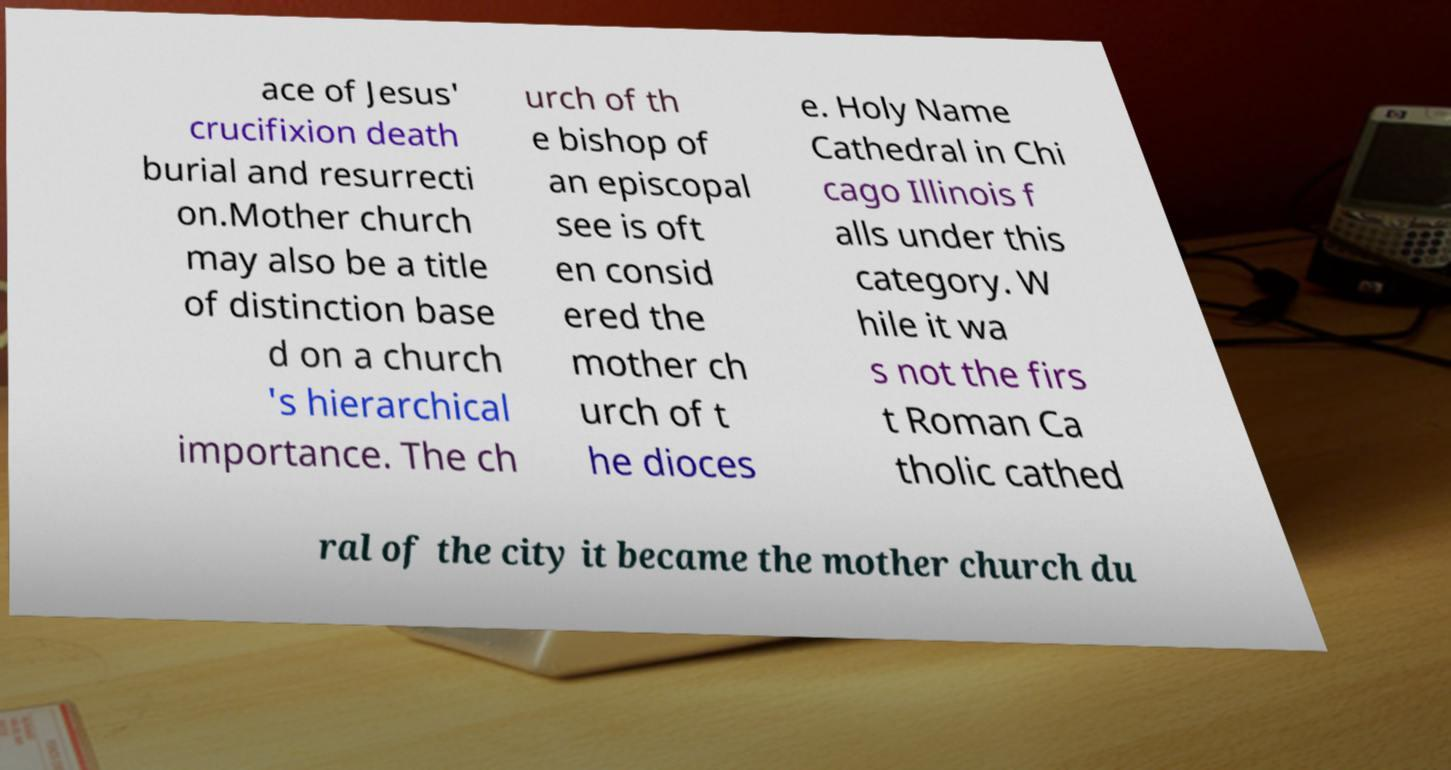Can you accurately transcribe the text from the provided image for me? ace of Jesus' crucifixion death burial and resurrecti on.Mother church may also be a title of distinction base d on a church 's hierarchical importance. The ch urch of th e bishop of an episcopal see is oft en consid ered the mother ch urch of t he dioces e. Holy Name Cathedral in Chi cago Illinois f alls under this category. W hile it wa s not the firs t Roman Ca tholic cathed ral of the city it became the mother church du 